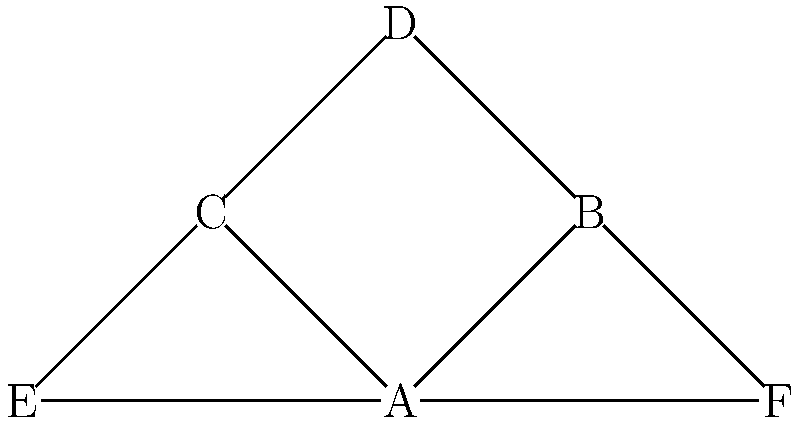Based on the network diagram of suspected criminal connections, which individual is most likely to be the central figure or leader of the operation? Justify your answer using network analysis principles. To determine the central figure or leader in this criminal network, we need to analyze the diagram using key network analysis principles:

1. Degree Centrality: Count the number of direct connections each node has.
   A: 4 connections
   B, C: 3 connections each
   D, E, F: 2 connections each

2. Betweenness Centrality: Identify nodes that act as bridges between other nodes.
   A appears to be on the most paths between other nodes.

3. Closeness Centrality: Evaluate how close each node is to all other nodes.
   A has the shortest average path to all other nodes.

4. Network Structure: Observe the overall shape and distribution of connections.
   The network has a star-like structure centered around A.

5. Strategic Position: Consider which node would have the best overview and control.
   A is positioned to have direct access to all parts of the network.

Given these observations, node A demonstrates the highest degree centrality, betweenness centrality, and closeness centrality. It occupies a strategic position at the center of the network, allowing for efficient information flow and control over other nodes.

In intelligence and criminal network analysis, such a position often indicates a leadership role or a key figure in the operation.
Answer: A is the most likely central figure/leader due to highest centrality measures and strategic network position. 